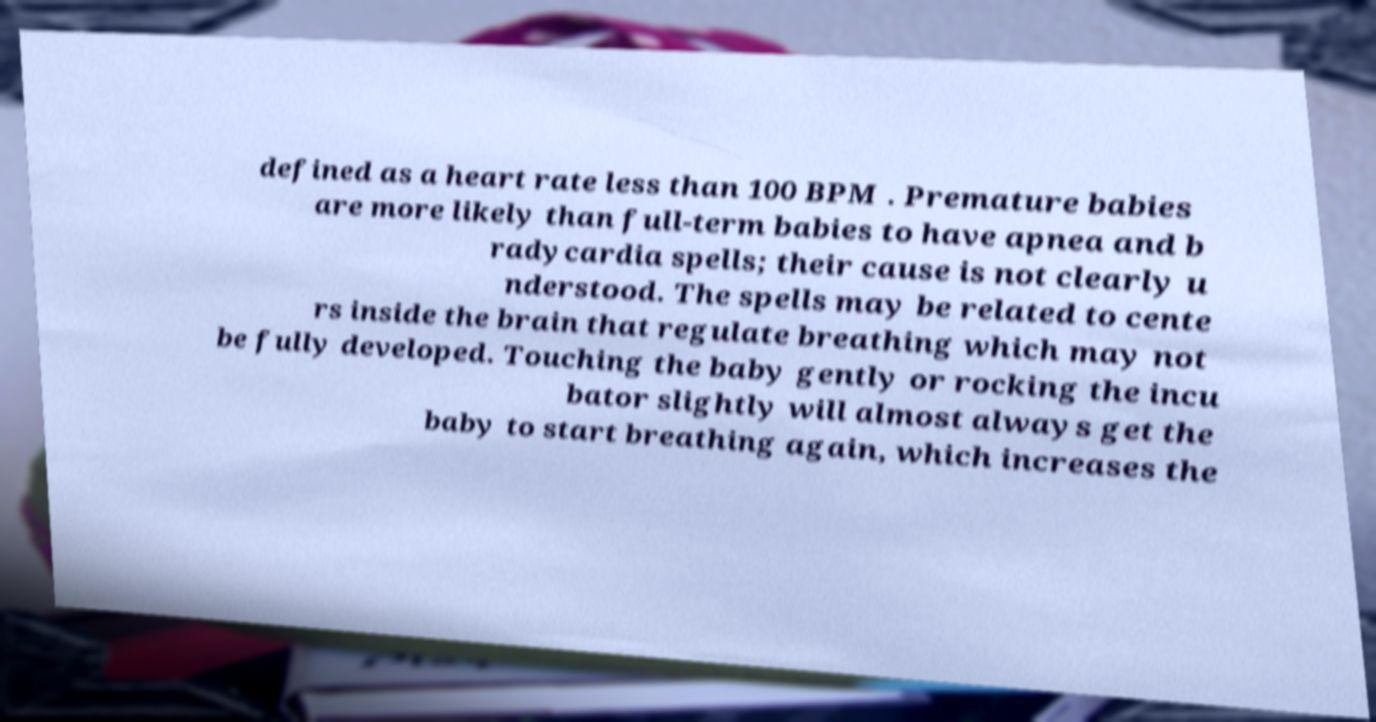I need the written content from this picture converted into text. Can you do that? defined as a heart rate less than 100 BPM . Premature babies are more likely than full-term babies to have apnea and b radycardia spells; their cause is not clearly u nderstood. The spells may be related to cente rs inside the brain that regulate breathing which may not be fully developed. Touching the baby gently or rocking the incu bator slightly will almost always get the baby to start breathing again, which increases the 